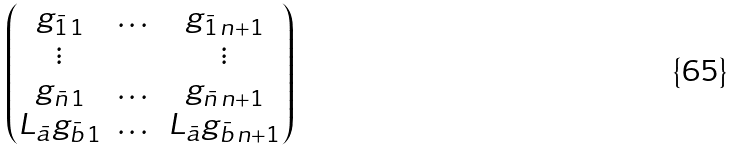Convert formula to latex. <formula><loc_0><loc_0><loc_500><loc_500>\begin{pmatrix} g _ { \bar { 1 } \, 1 } & \dots & g _ { \bar { 1 } \, n + 1 } \\ \vdots & & \vdots \\ g _ { \bar { n } \, 1 } & \dots & g _ { \bar { n } \, n + 1 } \\ L _ { \bar { a } } g _ { \bar { b } \, 1 } & \dots & L _ { \bar { a } } g _ { \bar { b } \, n + 1 } \end{pmatrix}</formula> 